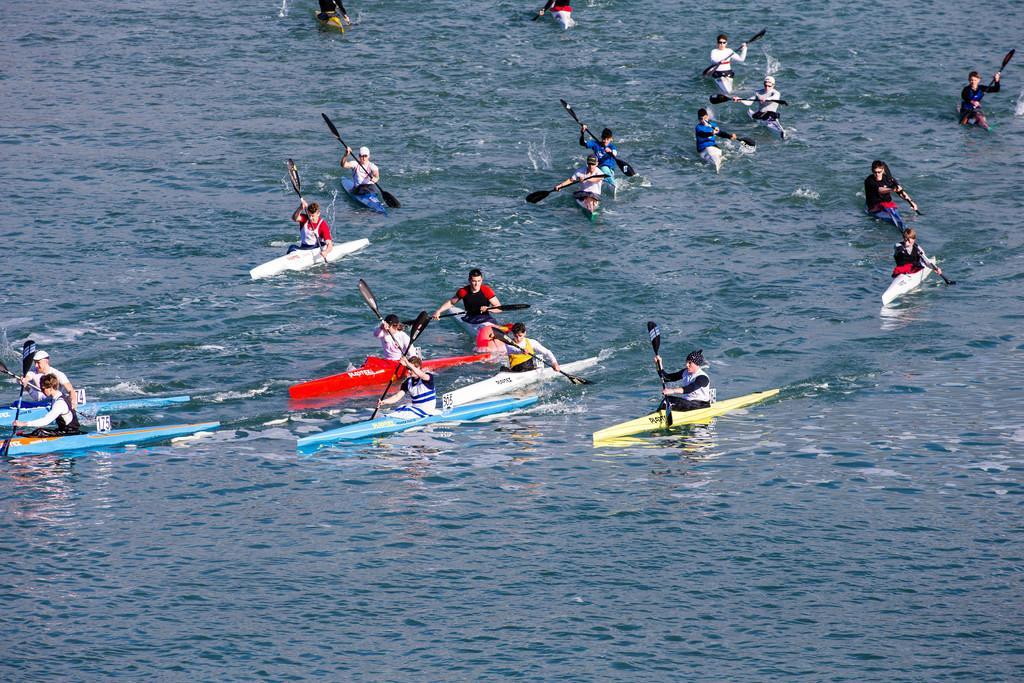Please provide a concise description of this image. In this image, we can see few people are sailing a boat on the water and holding paddles. 